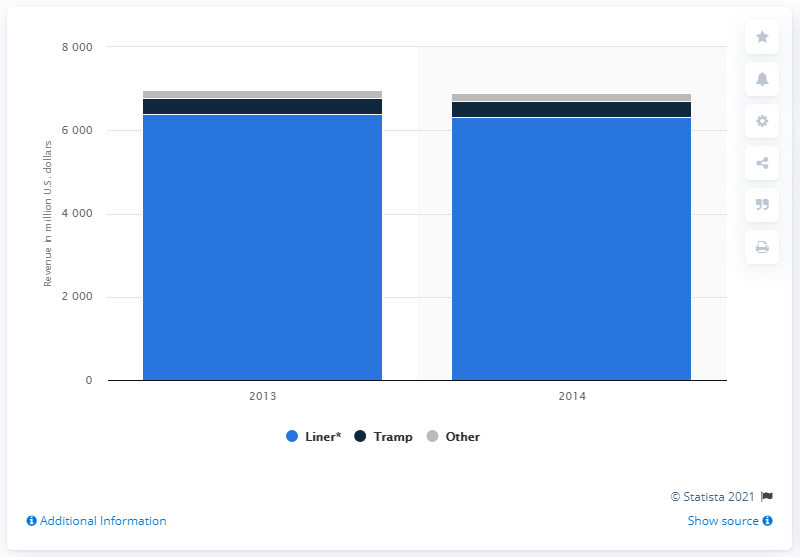Point out several critical features in this image. In 2013, Hamburg Süd generated approximately 6,399 from its liner segment. 